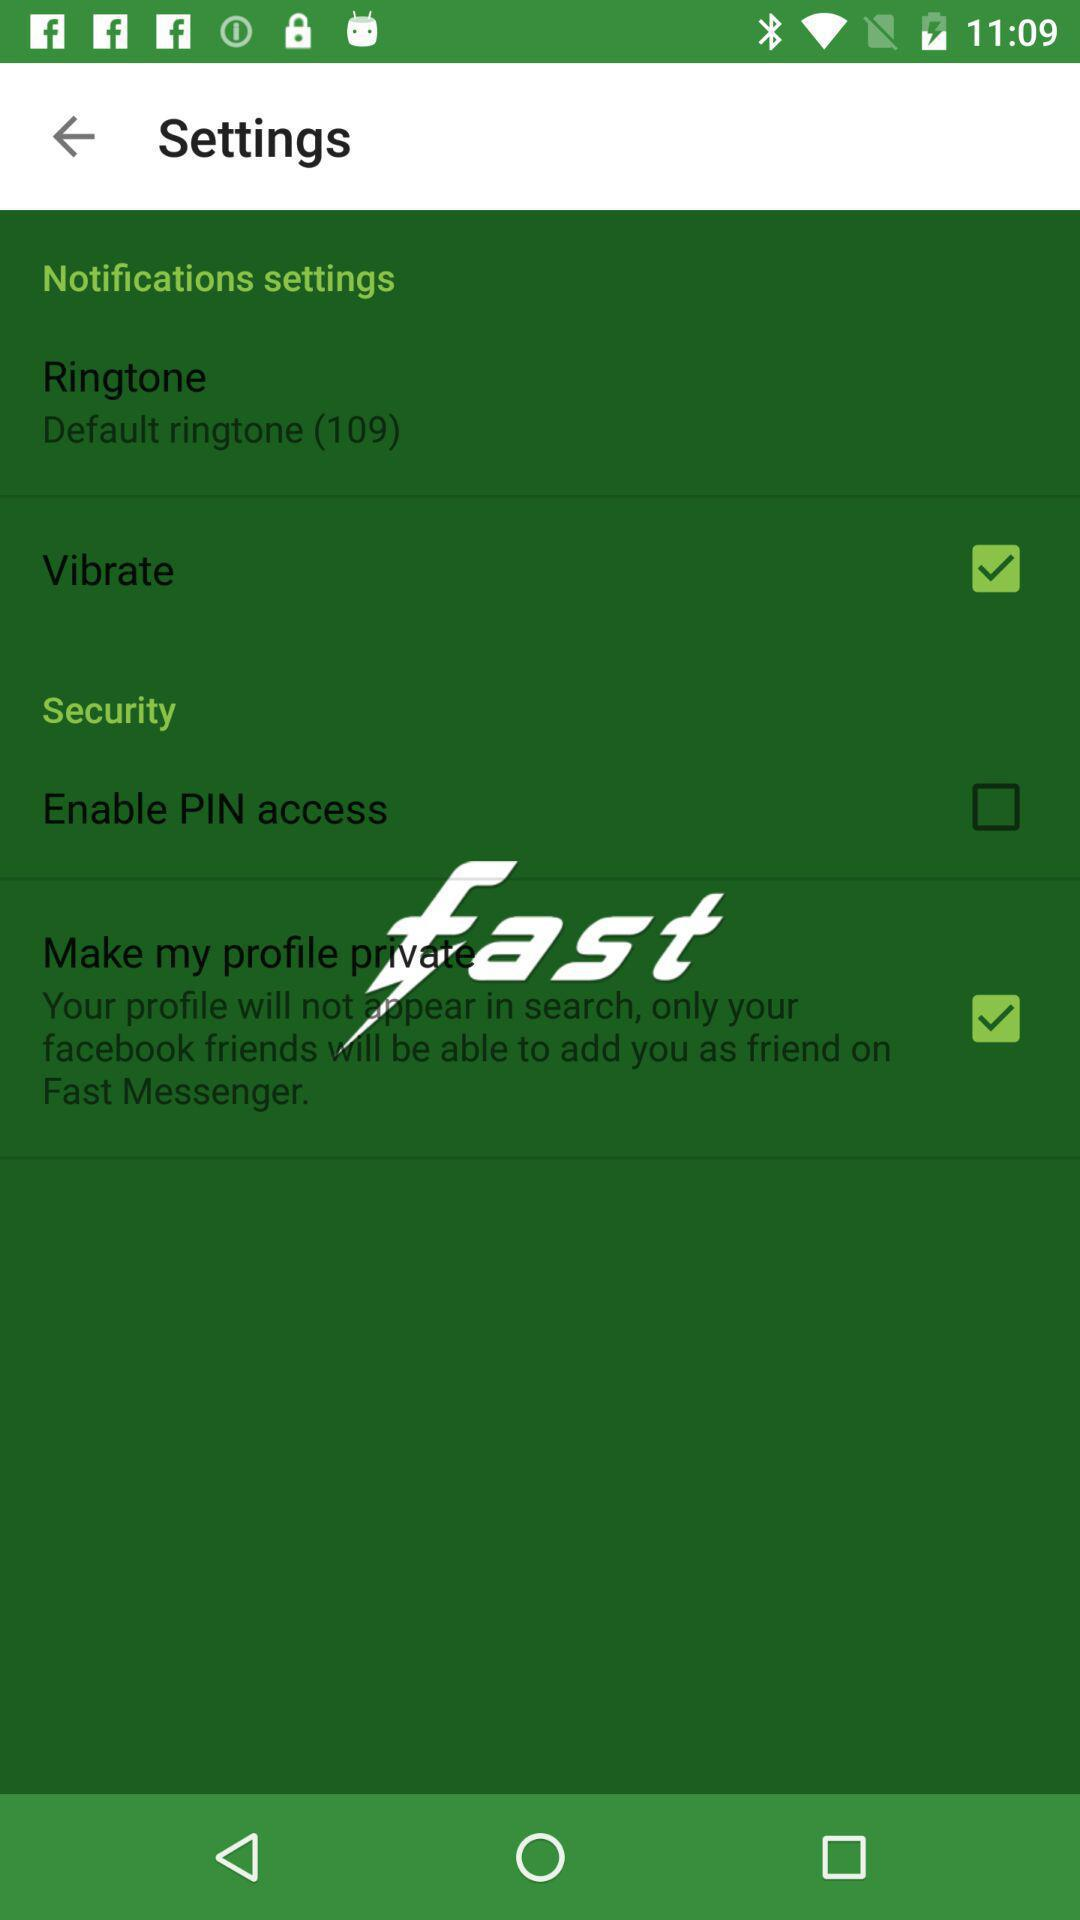What is the status of the "Make my profile private"? The status is "on". 